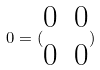<formula> <loc_0><loc_0><loc_500><loc_500>0 = ( \begin{matrix} 0 & 0 \\ 0 & 0 \end{matrix} )</formula> 